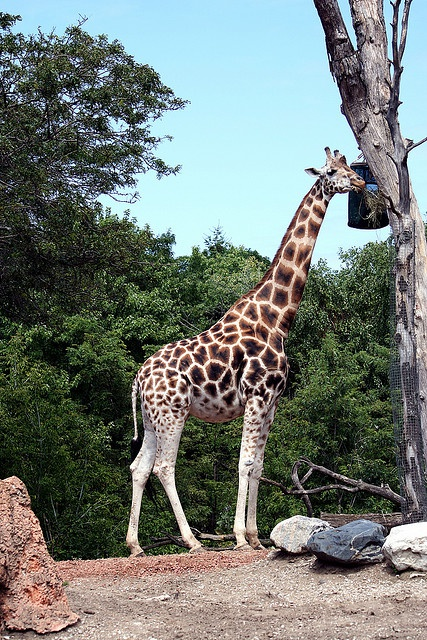Describe the objects in this image and their specific colors. I can see a giraffe in lightblue, ivory, black, darkgray, and brown tones in this image. 